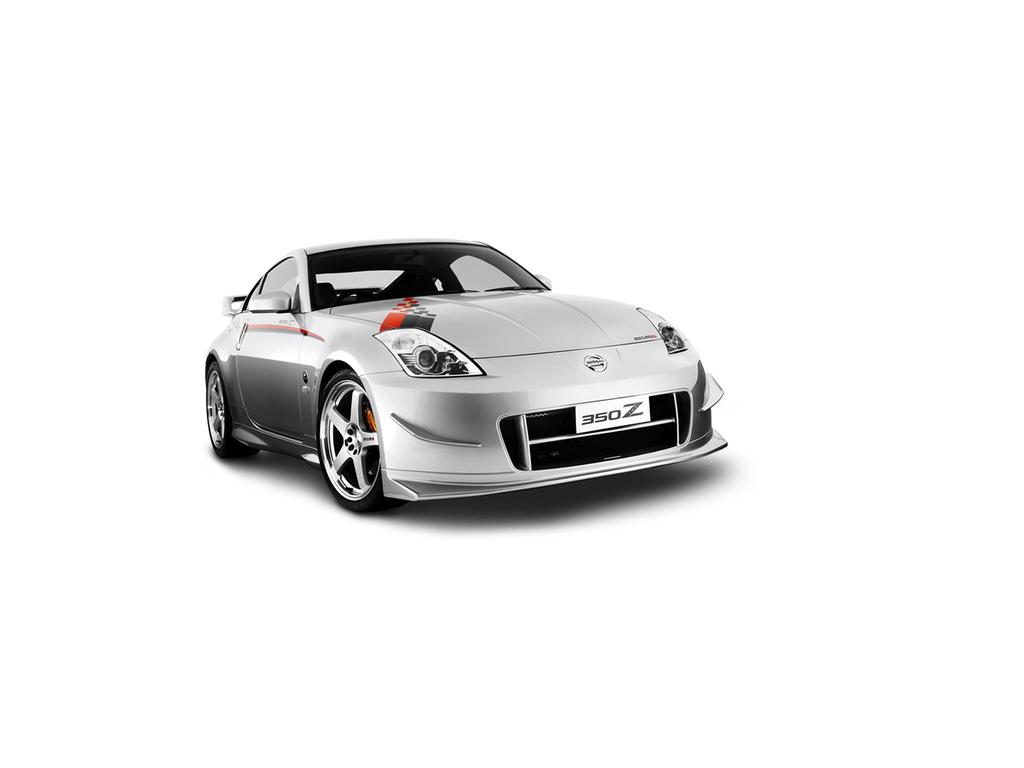What is the main subject of the image? There is a car in the center of the image. Where is the goat located in the image? There is no goat present in the image. What letter is written on the car's license plate in the image? The provided facts do not mention any details about the car's license plate, so we cannot determine the letter written on it. What type of blade is being used to cut the car in the image? There is no blade present in the image, and the car is not being cut. 